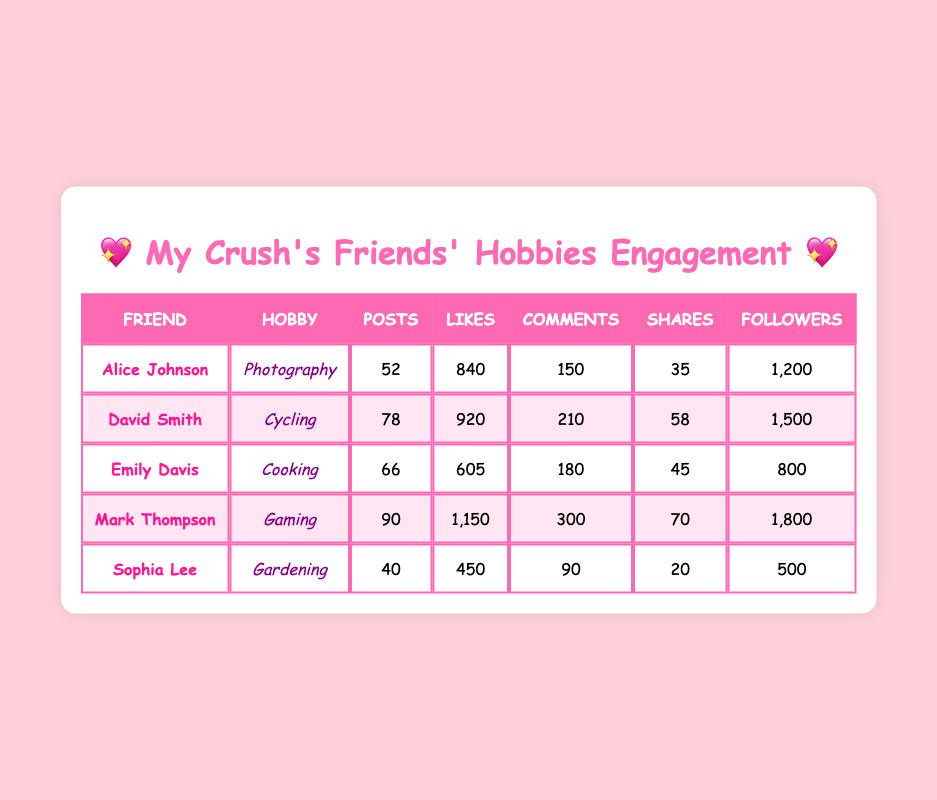What hobby has the highest number of followers? Mark Thompson has the highest number of followers at 1,800. We can find this by looking through the "Followers" column in the table and identifying the maximum value.
Answer: 1,800 Who posted the most this year? Mark Thompson posted the most, with a total of 90 posts. This can be determined by scanning the "Posts" column for the highest number.
Answer: Mark Thompson Is it true that Alice Johnson received more likes than Emily Davis? Yes, it's true. Alice Johnson has 840 likes while Emily Davis has 605 likes. By comparing their "Likes" values, we see Alice has more.
Answer: Yes What is the total number of likes received by all friends combined? To find the total number of likes, we add all likes: 840 + 920 + 605 + 1150 + 450 = 3965. This requires summing the values from the "Likes" column for each friend.
Answer: 3965 Which hobby has the least amount of shares? Sophia Lee's gardening hobby has the least amount of shares, totaling 20. By browsing through the "Shares" column, we see that it's the smallest number listed.
Answer: Gardening What is the average number of comments among the friends? We first find the total number of comments: 150 + 210 + 180 + 300 + 90 = 930. There are 5 friends, so we divide the total comments by 5, giving us 930/5 = 186.
Answer: 186 Which friend had the highest engagement in terms of likes compared to their posts? To find this, we calculate likes per post for all friends: Alice (840/52), David (920/78), Emily (605/66), Mark (1150/90), and Sophia (450/40). Mark has the highest engagement with 12.78 likes per post.
Answer: Mark Thompson Did David Smith have more posts than Sophia Lee? Yes, David Smith had more posts (78) compared to Sophia Lee (40). By directly comparing the "Posts" values of both friends, we confirm this.
Answer: Yes 